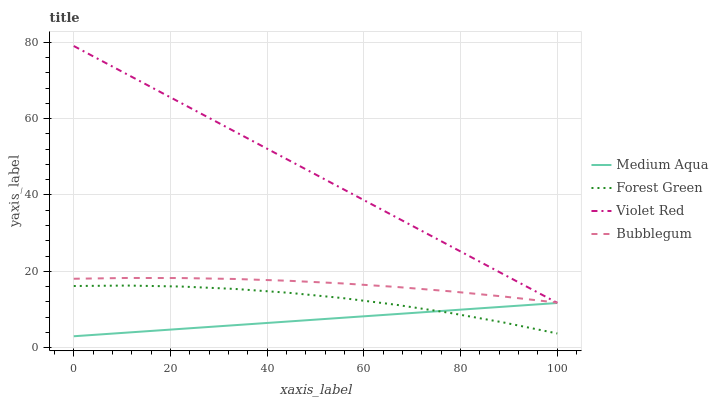Does Medium Aqua have the minimum area under the curve?
Answer yes or no. Yes. Does Violet Red have the maximum area under the curve?
Answer yes or no. Yes. Does Violet Red have the minimum area under the curve?
Answer yes or no. No. Does Medium Aqua have the maximum area under the curve?
Answer yes or no. No. Is Medium Aqua the smoothest?
Answer yes or no. Yes. Is Forest Green the roughest?
Answer yes or no. Yes. Is Violet Red the smoothest?
Answer yes or no. No. Is Violet Red the roughest?
Answer yes or no. No. Does Medium Aqua have the lowest value?
Answer yes or no. Yes. Does Violet Red have the lowest value?
Answer yes or no. No. Does Violet Red have the highest value?
Answer yes or no. Yes. Does Medium Aqua have the highest value?
Answer yes or no. No. Is Medium Aqua less than Bubblegum?
Answer yes or no. Yes. Is Violet Red greater than Medium Aqua?
Answer yes or no. Yes. Does Forest Green intersect Medium Aqua?
Answer yes or no. Yes. Is Forest Green less than Medium Aqua?
Answer yes or no. No. Is Forest Green greater than Medium Aqua?
Answer yes or no. No. Does Medium Aqua intersect Bubblegum?
Answer yes or no. No. 